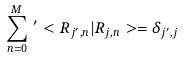<formula> <loc_0><loc_0><loc_500><loc_500>\sum _ { { n } = 0 } ^ { M } \, ^ { \prime } < R _ { j ^ { \prime } , { n } } | R _ { j , { n } } > = \delta _ { j ^ { \prime } , j }</formula> 